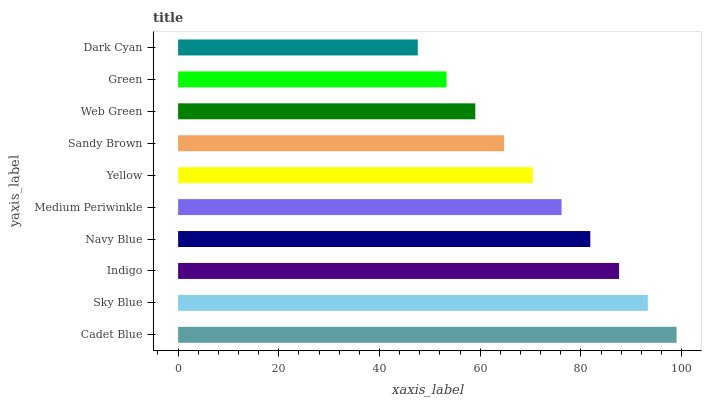Is Dark Cyan the minimum?
Answer yes or no. Yes. Is Cadet Blue the maximum?
Answer yes or no. Yes. Is Sky Blue the minimum?
Answer yes or no. No. Is Sky Blue the maximum?
Answer yes or no. No. Is Cadet Blue greater than Sky Blue?
Answer yes or no. Yes. Is Sky Blue less than Cadet Blue?
Answer yes or no. Yes. Is Sky Blue greater than Cadet Blue?
Answer yes or no. No. Is Cadet Blue less than Sky Blue?
Answer yes or no. No. Is Medium Periwinkle the high median?
Answer yes or no. Yes. Is Yellow the low median?
Answer yes or no. Yes. Is Sky Blue the high median?
Answer yes or no. No. Is Cadet Blue the low median?
Answer yes or no. No. 